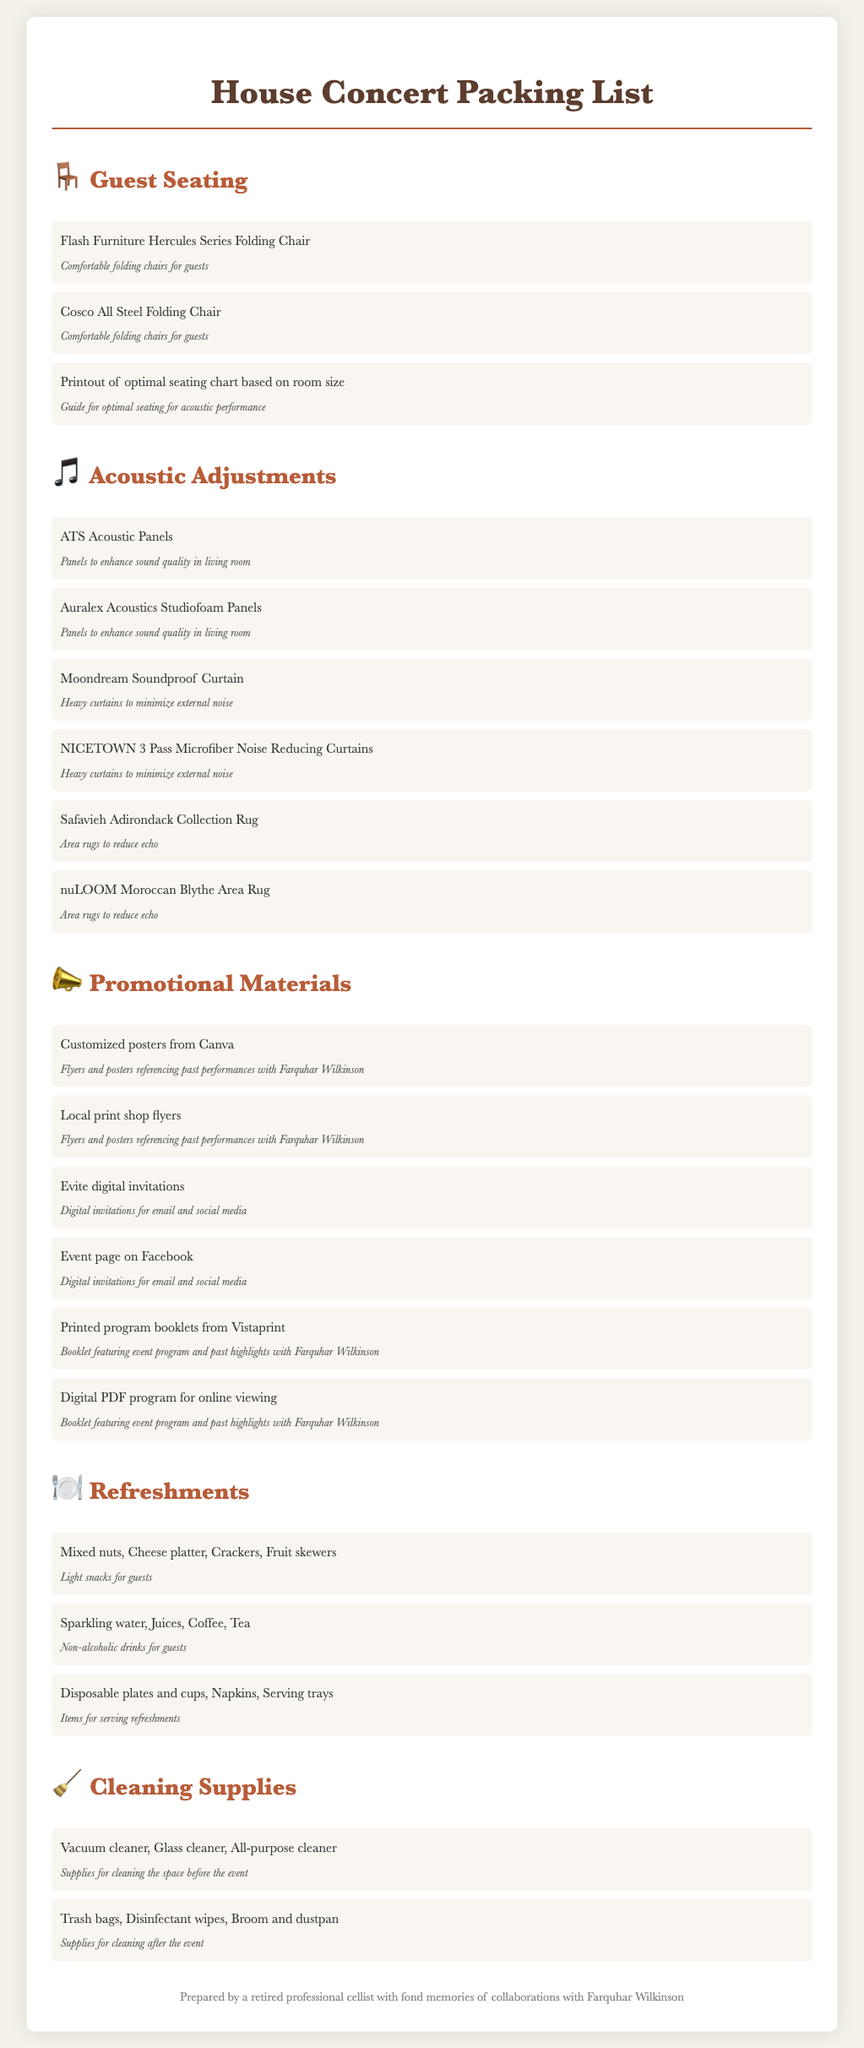What is the first item listed under Guest Seating? The first item listed is a folding chair specifically designed for guest seating during the concert.
Answer: Flash Furniture Hercules Series Folding Chair How many types of acoustic panels are mentioned? The document lists various types of acoustic panels to enhance the sound quality of the performance.
Answer: 2 What is included in the Refreshments section? The Refreshments section details light snacks and non-alcoholic drinks provided for the guests.
Answer: Mixed nuts, Cheese platter, Crackers, Fruit skewers What promotional material references past performances with Farquhar Wilkinson? The document indicates that certain promotional materials highlight collaborations with Farquhar Wilkinson.
Answer: Customized posters from Canva What supplies are specified for cleaning after the event? The document outlines a variety of cleaning supplies that are important for tidying up the space after the concert.
Answer: Trash bags, Disinfectant wipes, Broom and dustpan How many guest seating arrangements are mentioned in the document? The document includes a few different options for providing seating arrangements for guests during the concert.
Answer: 3 What is the purpose of printed program booklets from Vistaprint? The printed program booklets serve to inform guests about the event structure and highlights.
Answer: Booklet featuring event program and past highlights with Farquhar Wilkinson Which item is listed first under Acoustic Adjustments? The first item listed under Acoustic Adjustments is designed to enhance the living room's sound quality.
Answer: ATS Acoustic Panels How are the digital invitations categorized in the document? The digital invitations are included under the promotional materials section for easy access to event details.
Answer: Evite digital invitations 